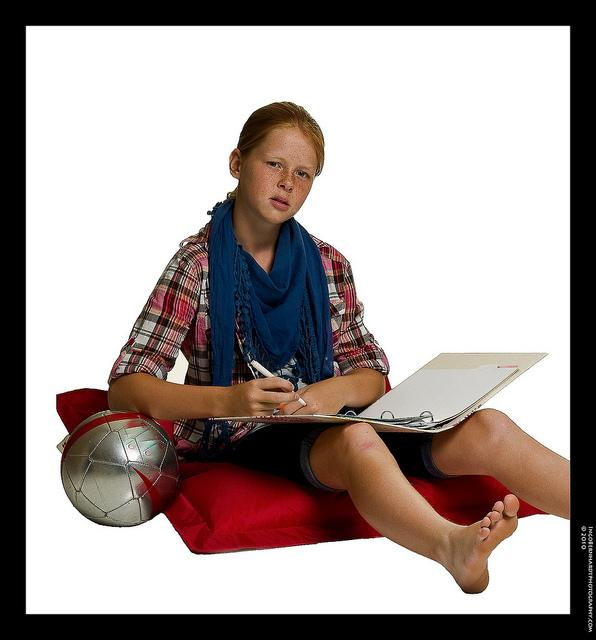What happened to the background?

Choices:
A) edited out
B) slightly overexposed
C) blurred
D) left unchanged edited out 